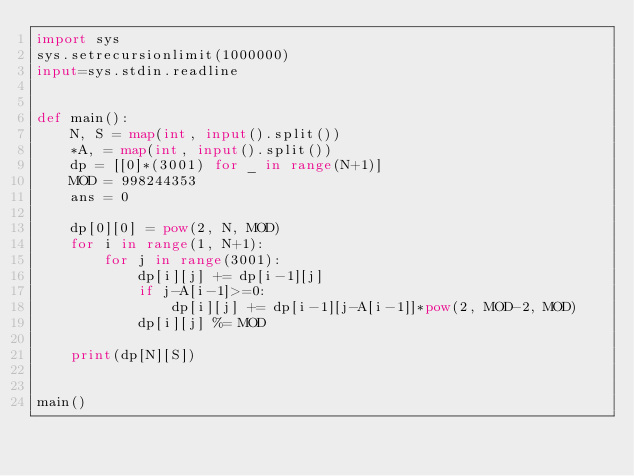<code> <loc_0><loc_0><loc_500><loc_500><_Python_>import sys
sys.setrecursionlimit(1000000)
input=sys.stdin.readline


def main():
    N, S = map(int, input().split())
    *A, = map(int, input().split())
    dp = [[0]*(3001) for _ in range(N+1)]
    MOD = 998244353
    ans = 0

    dp[0][0] = pow(2, N, MOD)
    for i in range(1, N+1):    
        for j in range(3001):
            dp[i][j] += dp[i-1][j]
            if j-A[i-1]>=0:
                dp[i][j] += dp[i-1][j-A[i-1]]*pow(2, MOD-2, MOD)
            dp[i][j] %= MOD

    print(dp[N][S])


main()</code> 